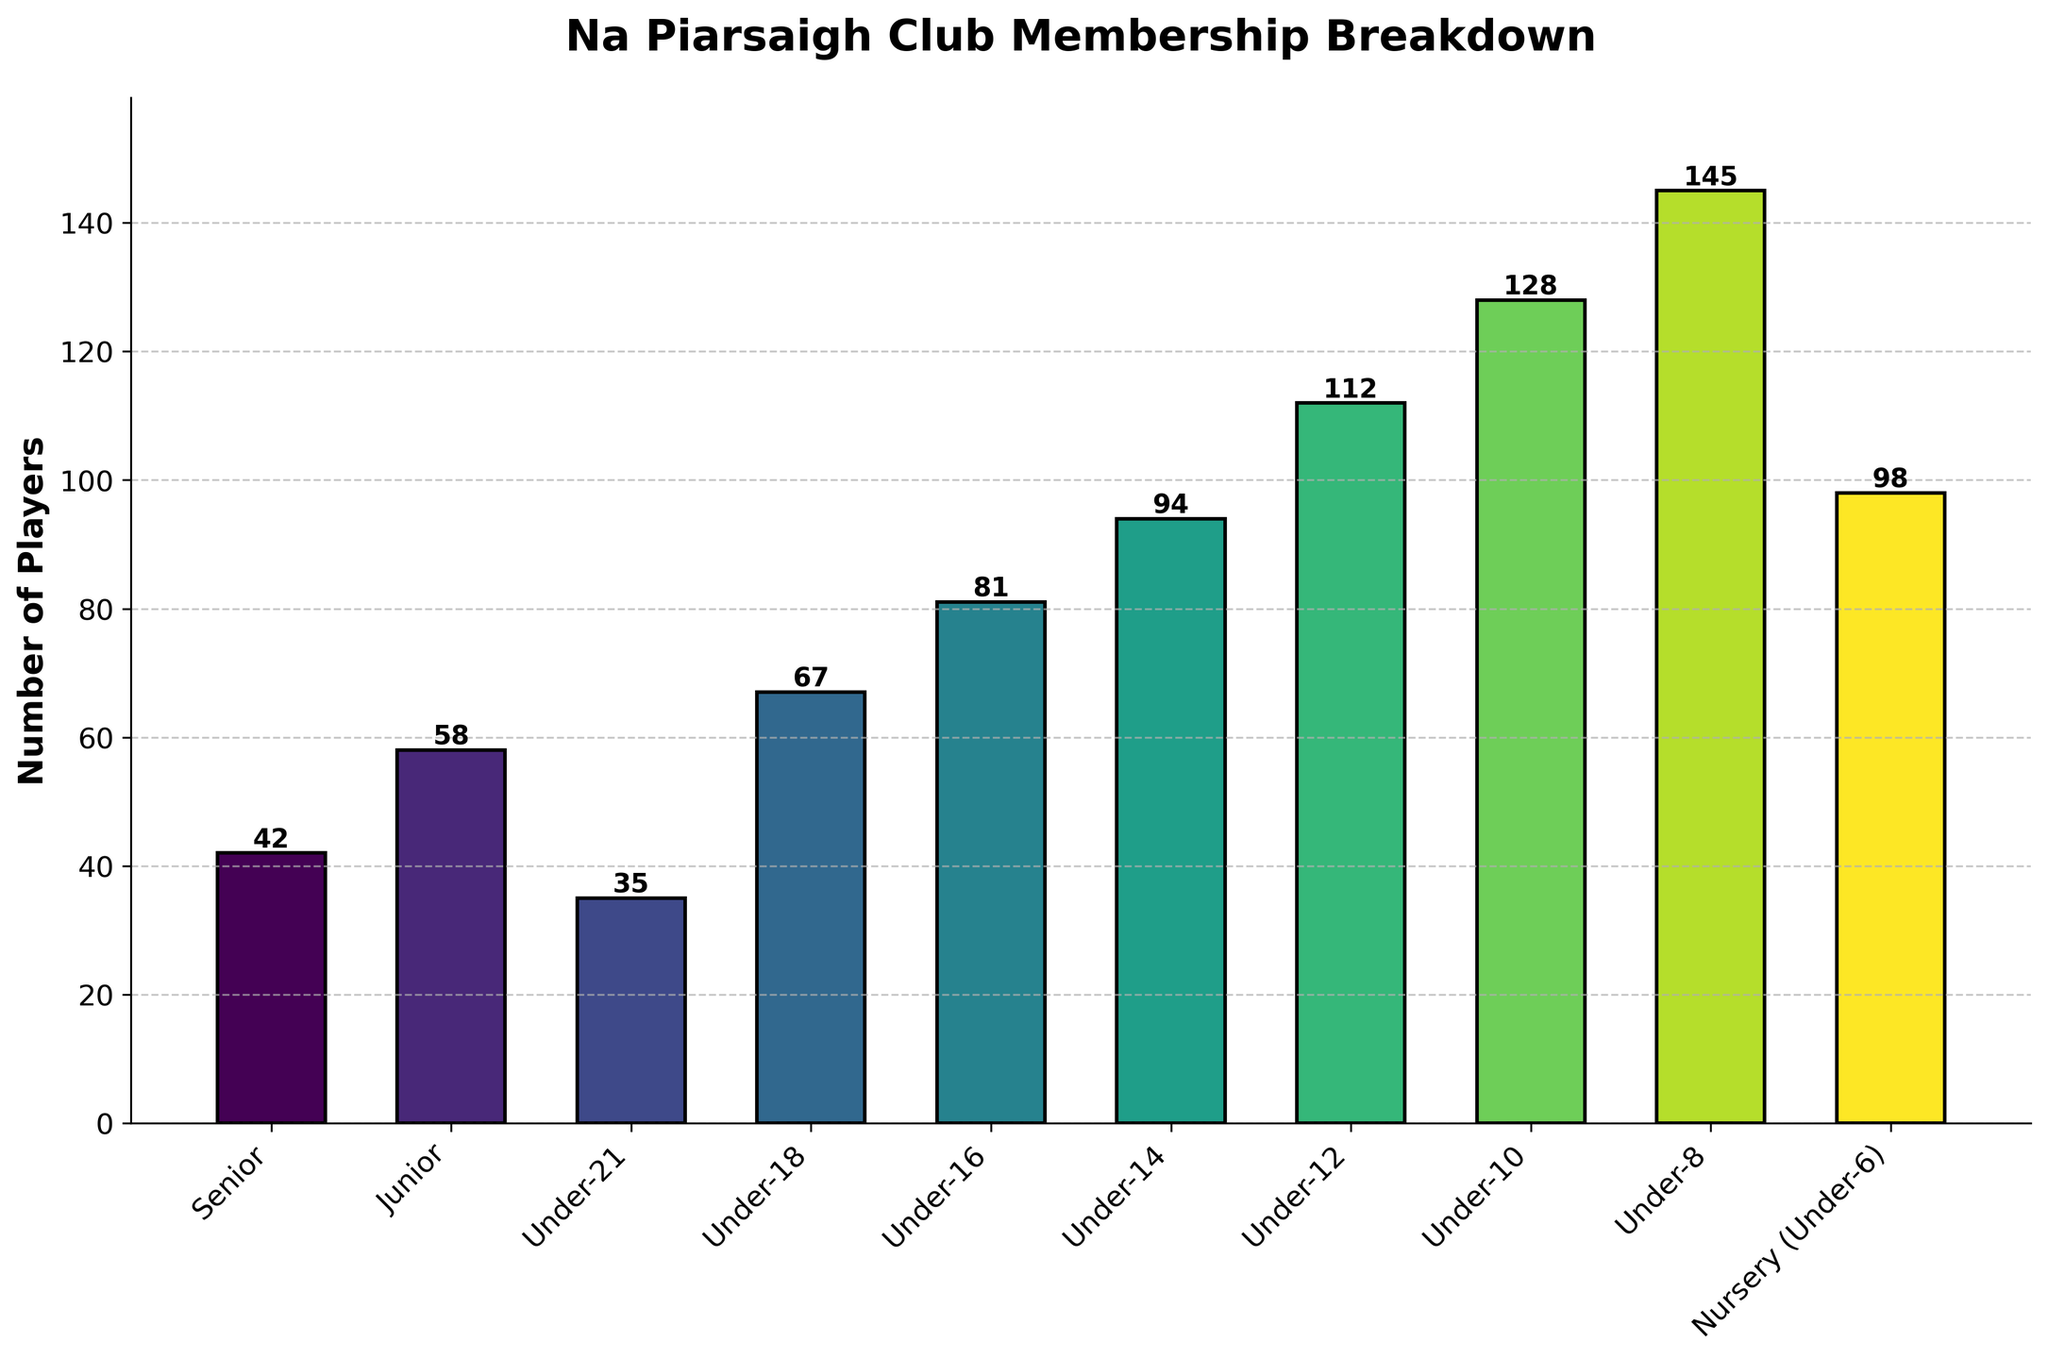Which player category has the highest number of players? Observing the heights of the bars, the Under-8 category has the tallest bar.
Answer: Under-8 Which player category has the lowest number of players? Observing the heights of the bars, the Senior category has the shortest bar.
Answer: Senior What is the difference in the number of players between the Under-8 and Nursery (Under-6) categories? The Under-8 category has 145 players, and the Nursery (Under-6) category has 98 players. The difference is 145 - 98.
Answer: 47 How many players are there in total across all categories? Summing up the numbers: 42 (Senior) + 58 (Junior) + 35 (Under-21) + 67 (Under-18) + 81 (Under-16) + 94 (Under-14) + 112 (Under-12) + 128 (Under-10) + 145 (Under-8) + 98 (Nursery) = 860.
Answer: 860 What is the average number of players per category? The total number of players is 860, and there are 10 categories. The average is 860 / 10.
Answer: 86 Which category has more players: Under-12 or Under-18? The Under-12 category has 112 players, while the Under-18 category has 67 players. Under-12 has more players.
Answer: Under-12 How does the number of Junior players compare to the number of Senior players? The Junior category has 58 players, and the Senior category has 42 players. The Junior category has more players.
Answer: Junior What is the sum of players in the Under-16 and Under-14 categories? The Under-16 category has 81 players, and the Under-14 category has 94 players. Their sum is 81 + 94.
Answer: 175 By how much does the number of players in the Under-10 category exceed that in the Junior category? The Under-10 category has 128 players, and the Junior category has 58 players. The difference is 128 - 58.
Answer: 70 Which category has the median number of players? Sorting the player numbers: 35, 42, 58, 67, 81, 94, 98, 112, 128, 145. The middle value (5th and 6th) averaging to 87.5, which in the sorted list lies between Under-16 and Under-14; goes to the higher side which is Under-14.
Answer: Under-14 